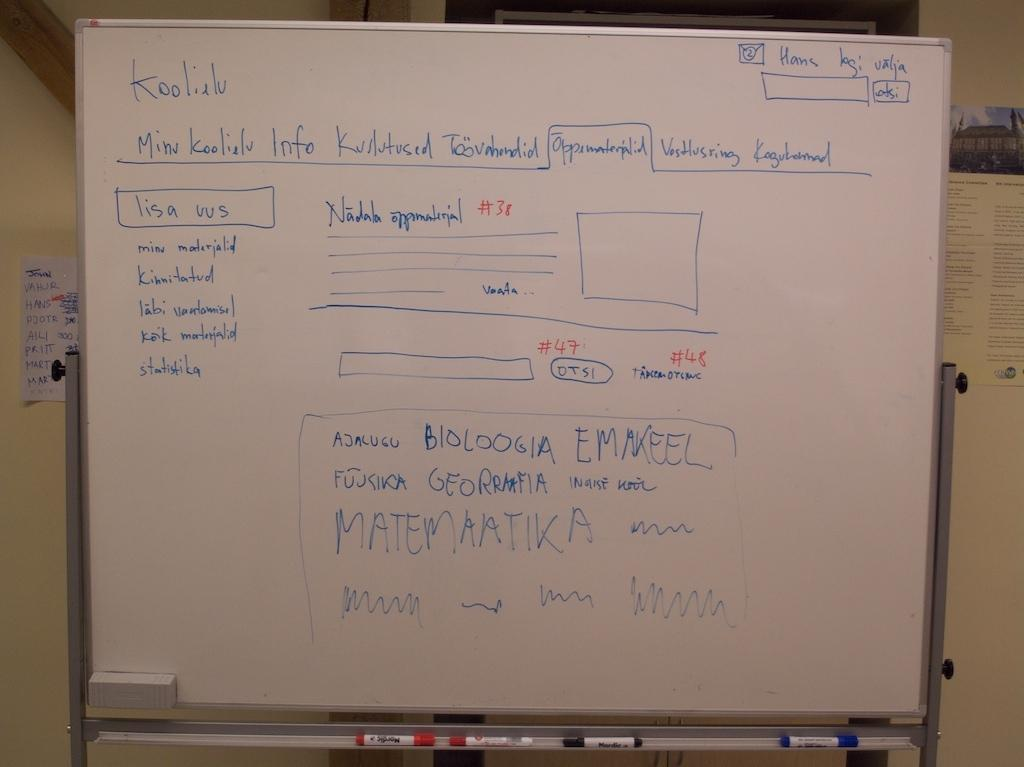<image>
Create a compact narrative representing the image presented. Handwritten notes on a whiteboard with #38 written in red. 